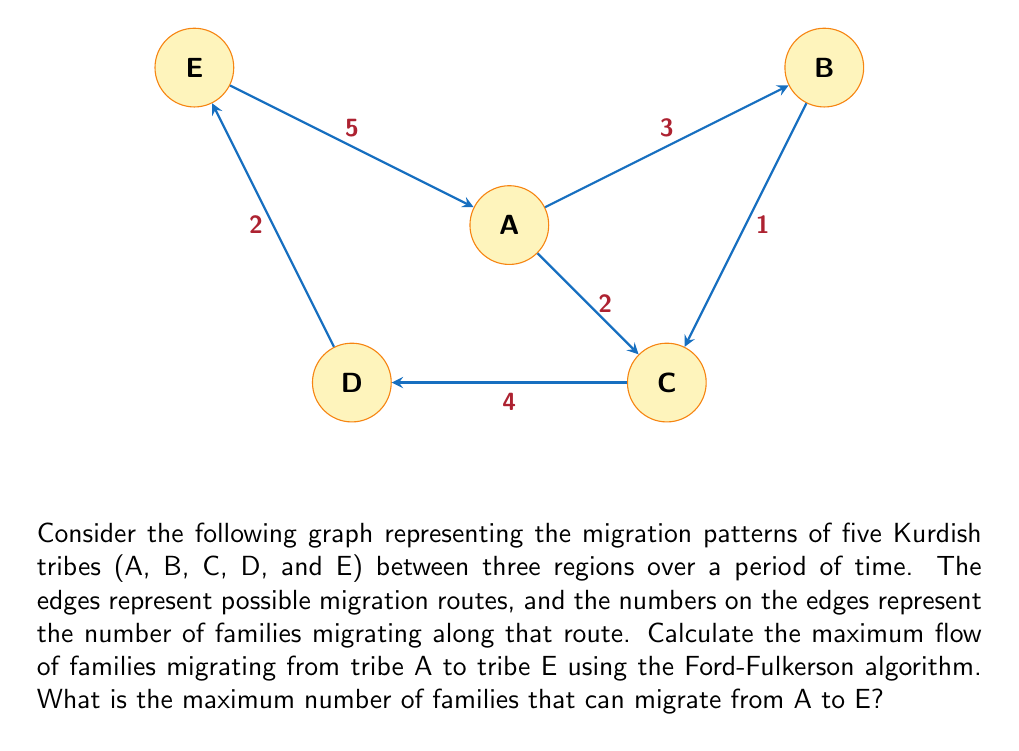Provide a solution to this math problem. To solve this problem using the Ford-Fulkerson algorithm, we'll follow these steps:

1) First, we need to identify the source (A) and sink (E) in our graph.

2) We'll then find augmenting paths from A to E and update the residual graph until no more augmenting paths exist.

3) The maximum flow will be the sum of the flows along all augmenting paths.

Let's start:

Step 1: Initial flow = 0

Step 2: Find augmenting path 1
Path: A -> B -> C -> D -> E
Minimum capacity along this path = min(3, 1, 4, 2) = 1
Update residual graph and add 1 to flow
Flow = 1

Step 3: Find augmenting path 2
Path: A -> C -> D -> E
Minimum capacity along this path = min(2, 4, 2) = 2
Update residual graph and add 2 to flow
Flow = 1 + 2 = 3

Step 4: Find augmenting path 3
Path: A -> B -> C -> D -> E
Minimum capacity along this path = min(2, 1, 3, 1) = 1
Update residual graph and add 1 to flow
Flow = 3 + 1 = 4

Step 5: No more augmenting paths exist

Therefore, the maximum flow from A to E is 4.

This can be verified by looking at the minimum cut in the graph:
Cut 1: {A, B, C} and {D, E}
Capacity of this cut = 4 + 2 = 6

Cut 2: {A, B} and {C, D, E}
Capacity of this cut = 3 + 2 = 5

Cut 3: {A} and {B, C, D, E}
Capacity of this cut = 3 + 2 = 5

The minimum cut has a capacity of 5, which is greater than our max flow of 4. This is because we have a bottleneck at D -> E with a capacity of 2.
Answer: 4 families 